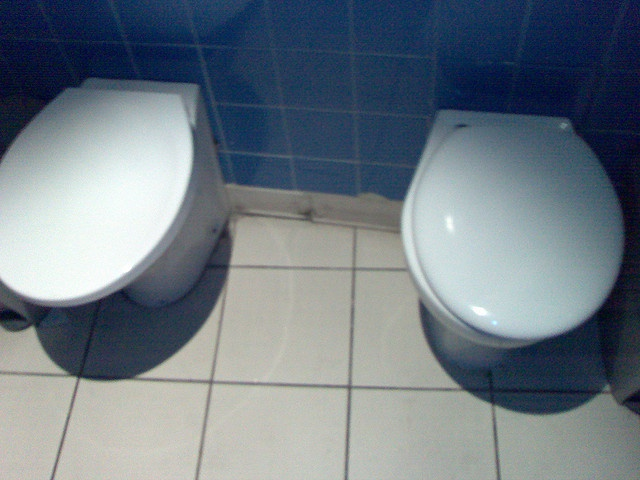Describe the objects in this image and their specific colors. I can see toilet in navy, darkgray, gray, lightgray, and lightblue tones and toilet in navy, white, gray, darkgray, and lightblue tones in this image. 